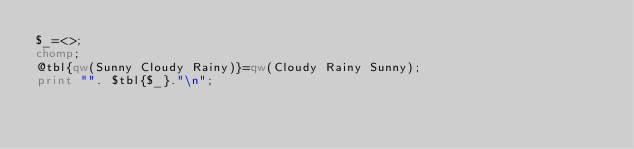<code> <loc_0><loc_0><loc_500><loc_500><_Perl_>$_=<>;
chomp;
@tbl{qw(Sunny Cloudy Rainy)}=qw(Cloudy Rainy Sunny);
print "". $tbl{$_}."\n";
</code> 